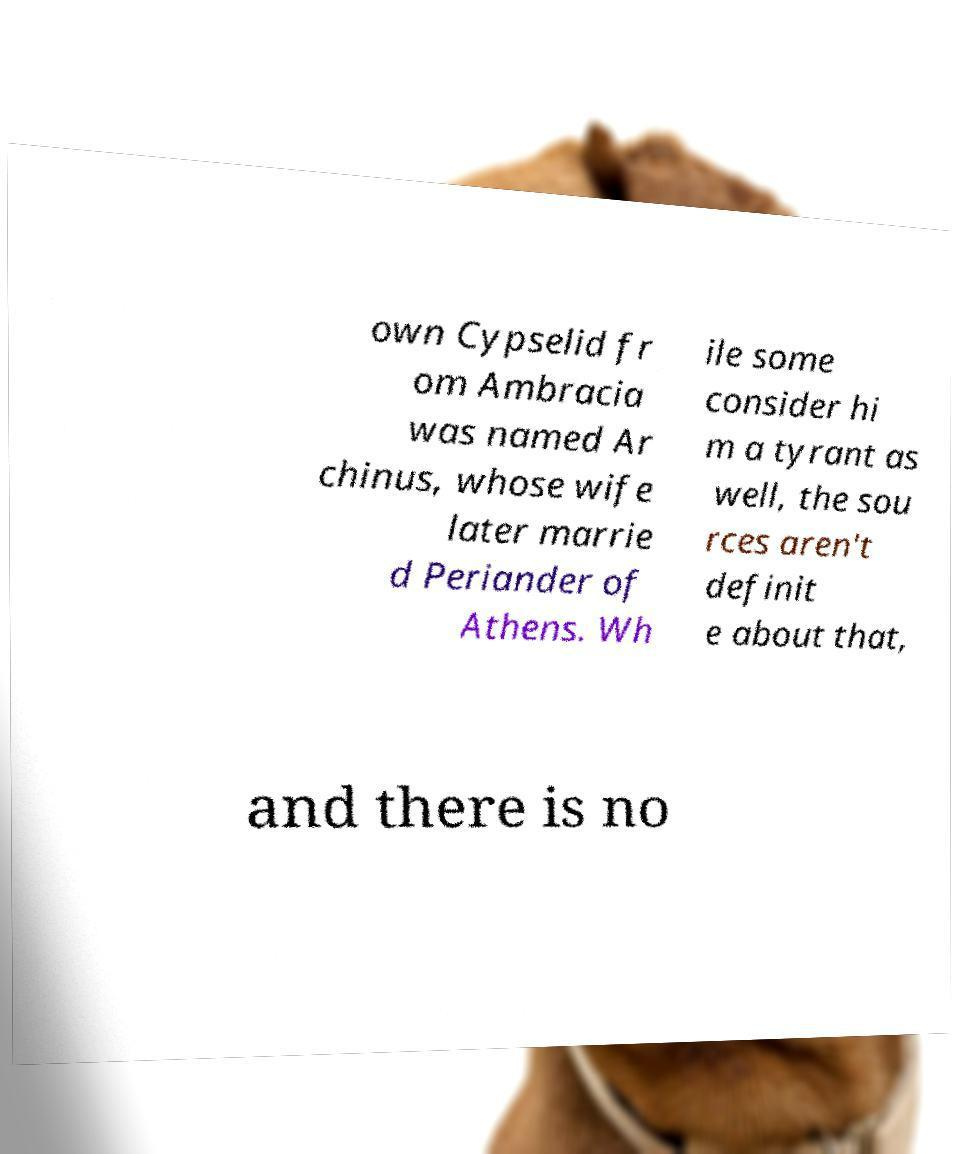I need the written content from this picture converted into text. Can you do that? own Cypselid fr om Ambracia was named Ar chinus, whose wife later marrie d Periander of Athens. Wh ile some consider hi m a tyrant as well, the sou rces aren't definit e about that, and there is no 